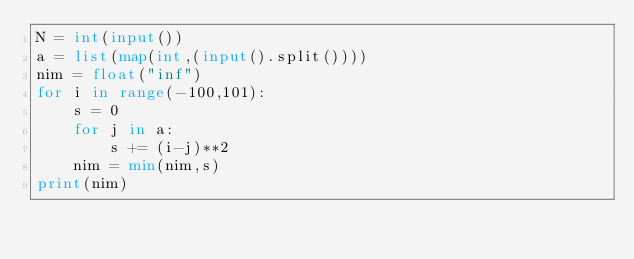Convert code to text. <code><loc_0><loc_0><loc_500><loc_500><_Python_>N = int(input())
a = list(map(int,(input().split())))
nim = float("inf")
for i in range(-100,101):
    s = 0
    for j in a:
        s += (i-j)**2
    nim = min(nim,s)
print(nim)</code> 